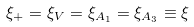Convert formula to latex. <formula><loc_0><loc_0><loc_500><loc_500>\xi _ { + } = \xi _ { V } = \xi _ { A _ { 1 } } = \xi _ { A _ { 3 } } \equiv \xi</formula> 